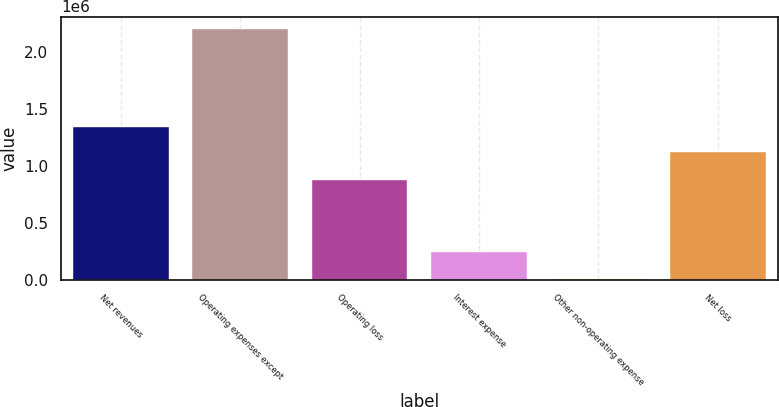Convert chart to OTSL. <chart><loc_0><loc_0><loc_500><loc_500><bar_chart><fcel>Net revenues<fcel>Operating expenses except<fcel>Operating loss<fcel>Interest expense<fcel>Other non-operating expense<fcel>Net loss<nl><fcel>1.3345e+06<fcel>2.19671e+06<fcel>870845<fcel>240731<fcel>3614<fcel>1.11519e+06<nl></chart> 